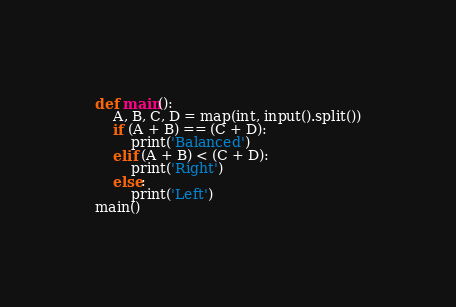Convert code to text. <code><loc_0><loc_0><loc_500><loc_500><_Python_>def main():
    A, B, C, D = map(int, input().split())
    if (A + B) == (C + D):
        print('Balanced')
    elif (A + B) < (C + D):
        print('Right')
    else:
        print('Left')
main()</code> 